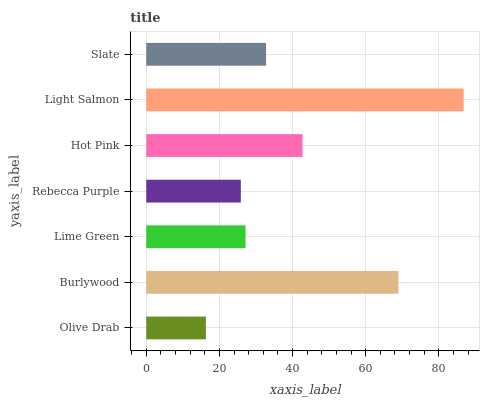Is Olive Drab the minimum?
Answer yes or no. Yes. Is Light Salmon the maximum?
Answer yes or no. Yes. Is Burlywood the minimum?
Answer yes or no. No. Is Burlywood the maximum?
Answer yes or no. No. Is Burlywood greater than Olive Drab?
Answer yes or no. Yes. Is Olive Drab less than Burlywood?
Answer yes or no. Yes. Is Olive Drab greater than Burlywood?
Answer yes or no. No. Is Burlywood less than Olive Drab?
Answer yes or no. No. Is Slate the high median?
Answer yes or no. Yes. Is Slate the low median?
Answer yes or no. Yes. Is Light Salmon the high median?
Answer yes or no. No. Is Lime Green the low median?
Answer yes or no. No. 